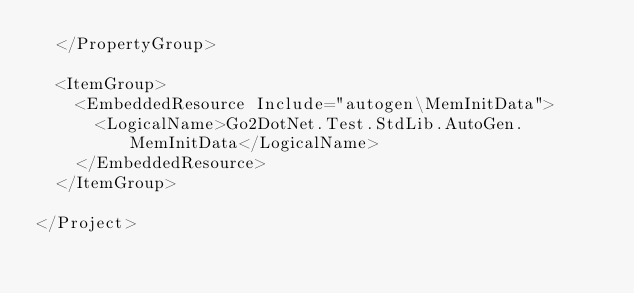Convert code to text. <code><loc_0><loc_0><loc_500><loc_500><_XML_>  </PropertyGroup>

  <ItemGroup>
    <EmbeddedResource Include="autogen\MemInitData">
      <LogicalName>Go2DotNet.Test.StdLib.AutoGen.MemInitData</LogicalName>
    </EmbeddedResource>
  </ItemGroup>

</Project>
</code> 